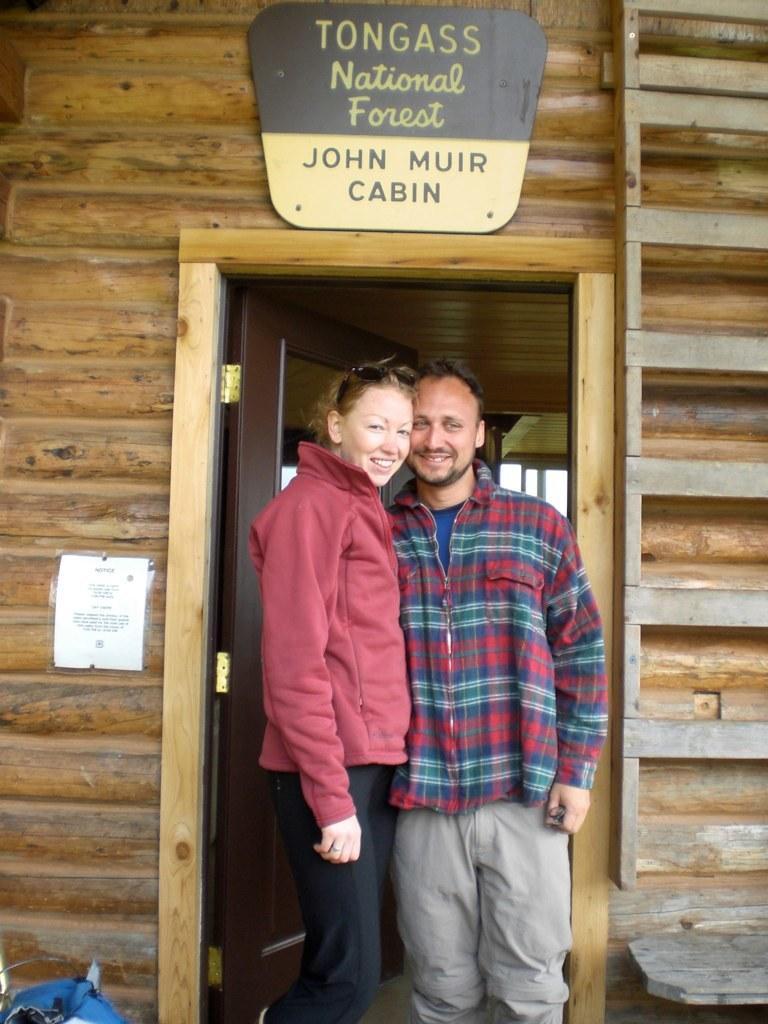How would you summarize this image in a sentence or two? In the image there are two people standing in front of a door and posing for the photo, around the door there is a wooden wall and some frame attached to the wall, on the left side there is a poster. 